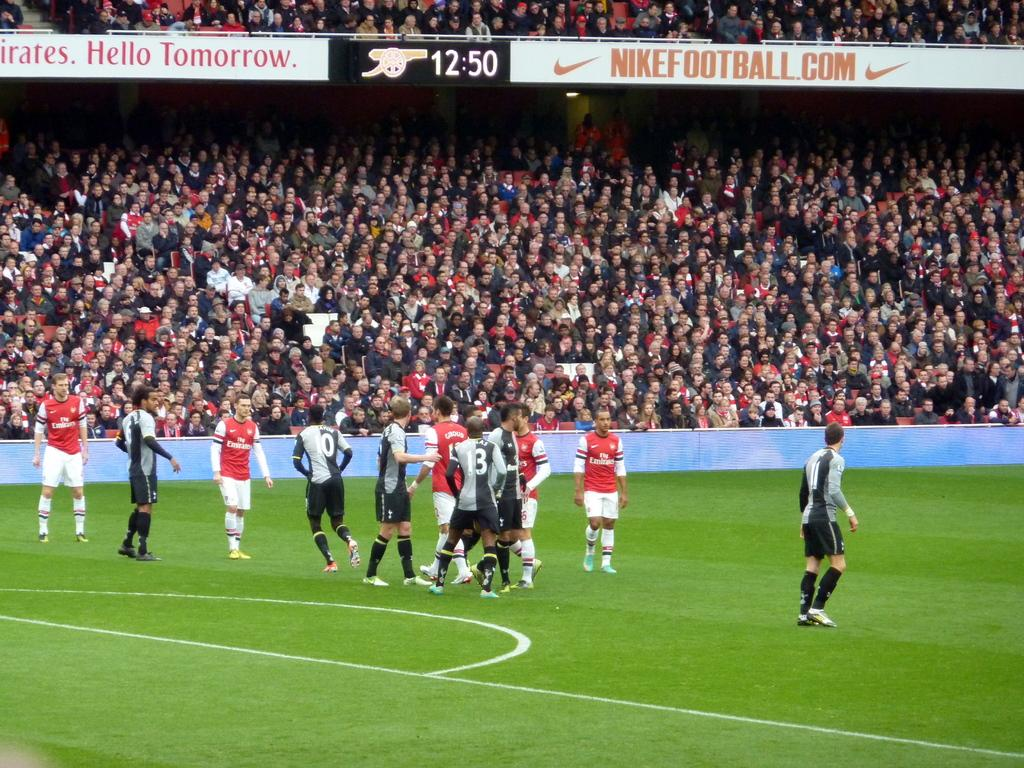<image>
Create a compact narrative representing the image presented. Soccer players are standing around on the field below the Nike ad. 